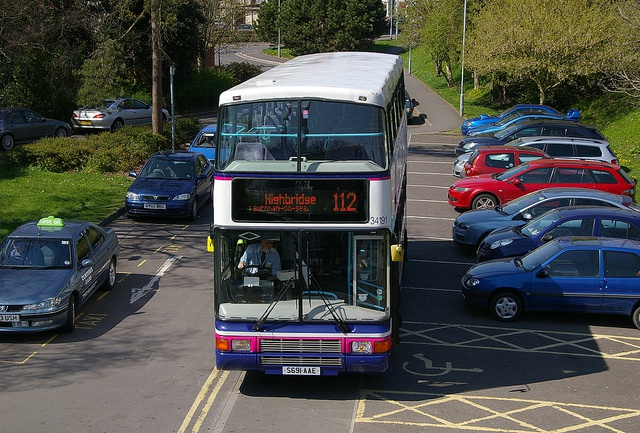Describe the objects in this image and their specific colors. I can see bus in black, lightgray, gray, and navy tones, car in black, navy, blue, and gray tones, car in black, blue, navy, and gray tones, car in black, brown, navy, and maroon tones, and car in black, navy, gray, and blue tones in this image. 